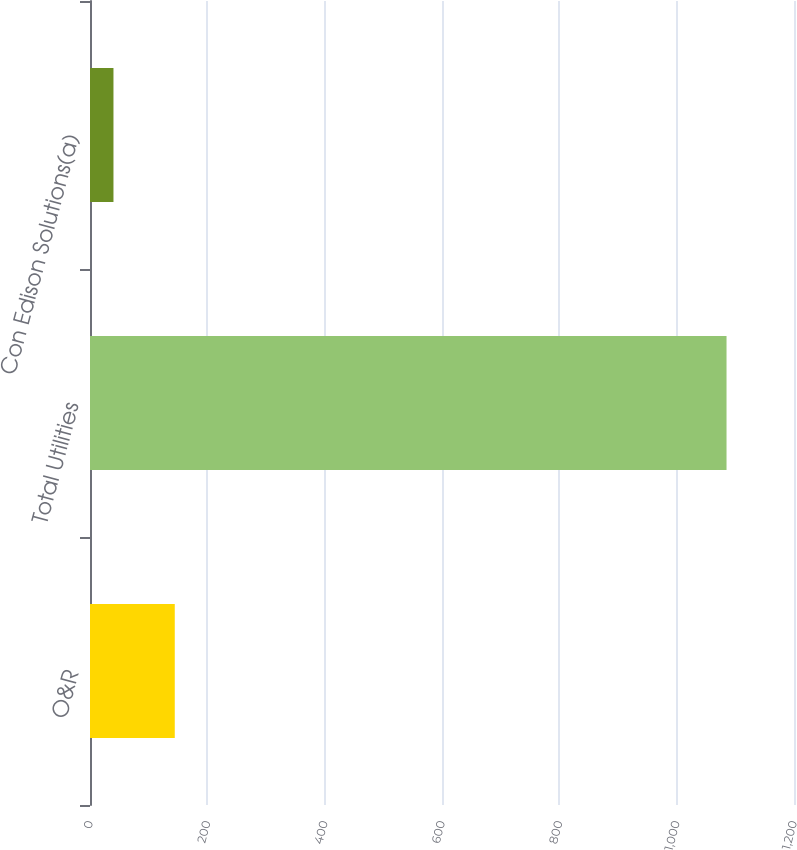<chart> <loc_0><loc_0><loc_500><loc_500><bar_chart><fcel>O&R<fcel>Total Utilities<fcel>Con Edison Solutions(a)<nl><fcel>144.5<fcel>1085<fcel>40<nl></chart> 